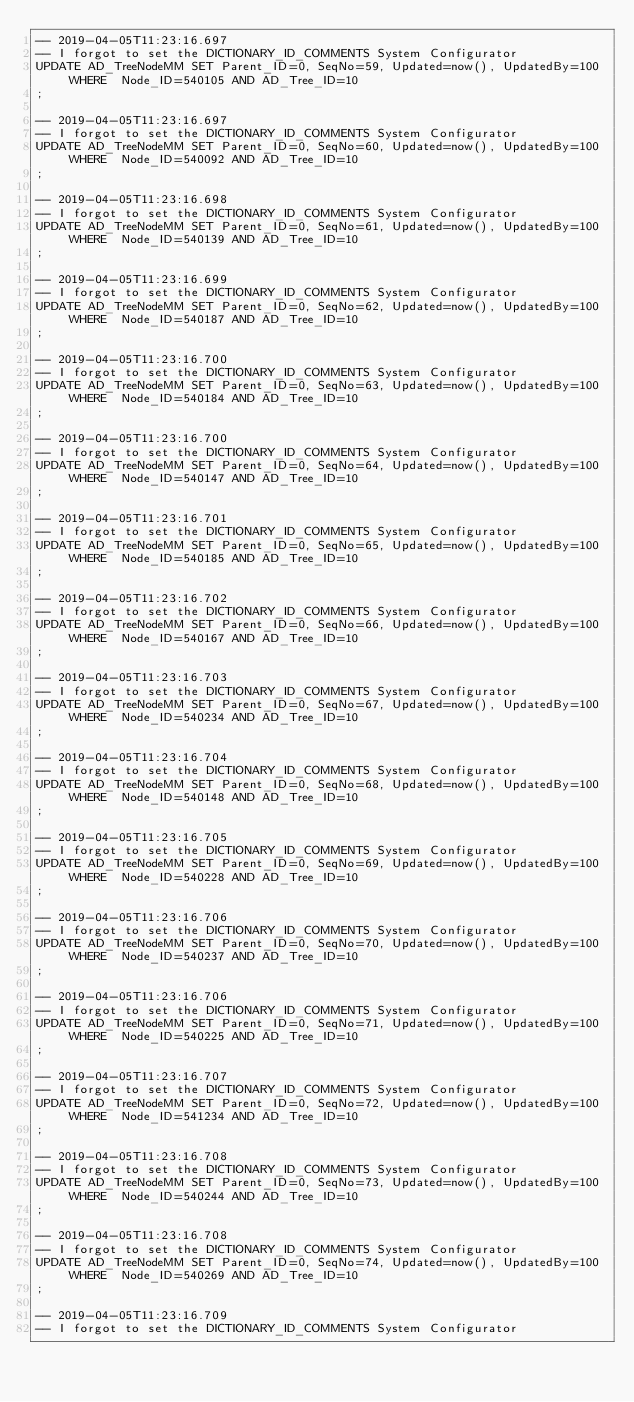Convert code to text. <code><loc_0><loc_0><loc_500><loc_500><_SQL_>-- 2019-04-05T11:23:16.697
-- I forgot to set the DICTIONARY_ID_COMMENTS System Configurator
UPDATE AD_TreeNodeMM SET Parent_ID=0, SeqNo=59, Updated=now(), UpdatedBy=100 WHERE  Node_ID=540105 AND AD_Tree_ID=10
;

-- 2019-04-05T11:23:16.697
-- I forgot to set the DICTIONARY_ID_COMMENTS System Configurator
UPDATE AD_TreeNodeMM SET Parent_ID=0, SeqNo=60, Updated=now(), UpdatedBy=100 WHERE  Node_ID=540092 AND AD_Tree_ID=10
;

-- 2019-04-05T11:23:16.698
-- I forgot to set the DICTIONARY_ID_COMMENTS System Configurator
UPDATE AD_TreeNodeMM SET Parent_ID=0, SeqNo=61, Updated=now(), UpdatedBy=100 WHERE  Node_ID=540139 AND AD_Tree_ID=10
;

-- 2019-04-05T11:23:16.699
-- I forgot to set the DICTIONARY_ID_COMMENTS System Configurator
UPDATE AD_TreeNodeMM SET Parent_ID=0, SeqNo=62, Updated=now(), UpdatedBy=100 WHERE  Node_ID=540187 AND AD_Tree_ID=10
;

-- 2019-04-05T11:23:16.700
-- I forgot to set the DICTIONARY_ID_COMMENTS System Configurator
UPDATE AD_TreeNodeMM SET Parent_ID=0, SeqNo=63, Updated=now(), UpdatedBy=100 WHERE  Node_ID=540184 AND AD_Tree_ID=10
;

-- 2019-04-05T11:23:16.700
-- I forgot to set the DICTIONARY_ID_COMMENTS System Configurator
UPDATE AD_TreeNodeMM SET Parent_ID=0, SeqNo=64, Updated=now(), UpdatedBy=100 WHERE  Node_ID=540147 AND AD_Tree_ID=10
;

-- 2019-04-05T11:23:16.701
-- I forgot to set the DICTIONARY_ID_COMMENTS System Configurator
UPDATE AD_TreeNodeMM SET Parent_ID=0, SeqNo=65, Updated=now(), UpdatedBy=100 WHERE  Node_ID=540185 AND AD_Tree_ID=10
;

-- 2019-04-05T11:23:16.702
-- I forgot to set the DICTIONARY_ID_COMMENTS System Configurator
UPDATE AD_TreeNodeMM SET Parent_ID=0, SeqNo=66, Updated=now(), UpdatedBy=100 WHERE  Node_ID=540167 AND AD_Tree_ID=10
;

-- 2019-04-05T11:23:16.703
-- I forgot to set the DICTIONARY_ID_COMMENTS System Configurator
UPDATE AD_TreeNodeMM SET Parent_ID=0, SeqNo=67, Updated=now(), UpdatedBy=100 WHERE  Node_ID=540234 AND AD_Tree_ID=10
;

-- 2019-04-05T11:23:16.704
-- I forgot to set the DICTIONARY_ID_COMMENTS System Configurator
UPDATE AD_TreeNodeMM SET Parent_ID=0, SeqNo=68, Updated=now(), UpdatedBy=100 WHERE  Node_ID=540148 AND AD_Tree_ID=10
;

-- 2019-04-05T11:23:16.705
-- I forgot to set the DICTIONARY_ID_COMMENTS System Configurator
UPDATE AD_TreeNodeMM SET Parent_ID=0, SeqNo=69, Updated=now(), UpdatedBy=100 WHERE  Node_ID=540228 AND AD_Tree_ID=10
;

-- 2019-04-05T11:23:16.706
-- I forgot to set the DICTIONARY_ID_COMMENTS System Configurator
UPDATE AD_TreeNodeMM SET Parent_ID=0, SeqNo=70, Updated=now(), UpdatedBy=100 WHERE  Node_ID=540237 AND AD_Tree_ID=10
;

-- 2019-04-05T11:23:16.706
-- I forgot to set the DICTIONARY_ID_COMMENTS System Configurator
UPDATE AD_TreeNodeMM SET Parent_ID=0, SeqNo=71, Updated=now(), UpdatedBy=100 WHERE  Node_ID=540225 AND AD_Tree_ID=10
;

-- 2019-04-05T11:23:16.707
-- I forgot to set the DICTIONARY_ID_COMMENTS System Configurator
UPDATE AD_TreeNodeMM SET Parent_ID=0, SeqNo=72, Updated=now(), UpdatedBy=100 WHERE  Node_ID=541234 AND AD_Tree_ID=10
;

-- 2019-04-05T11:23:16.708
-- I forgot to set the DICTIONARY_ID_COMMENTS System Configurator
UPDATE AD_TreeNodeMM SET Parent_ID=0, SeqNo=73, Updated=now(), UpdatedBy=100 WHERE  Node_ID=540244 AND AD_Tree_ID=10
;

-- 2019-04-05T11:23:16.708
-- I forgot to set the DICTIONARY_ID_COMMENTS System Configurator
UPDATE AD_TreeNodeMM SET Parent_ID=0, SeqNo=74, Updated=now(), UpdatedBy=100 WHERE  Node_ID=540269 AND AD_Tree_ID=10
;

-- 2019-04-05T11:23:16.709
-- I forgot to set the DICTIONARY_ID_COMMENTS System Configurator</code> 